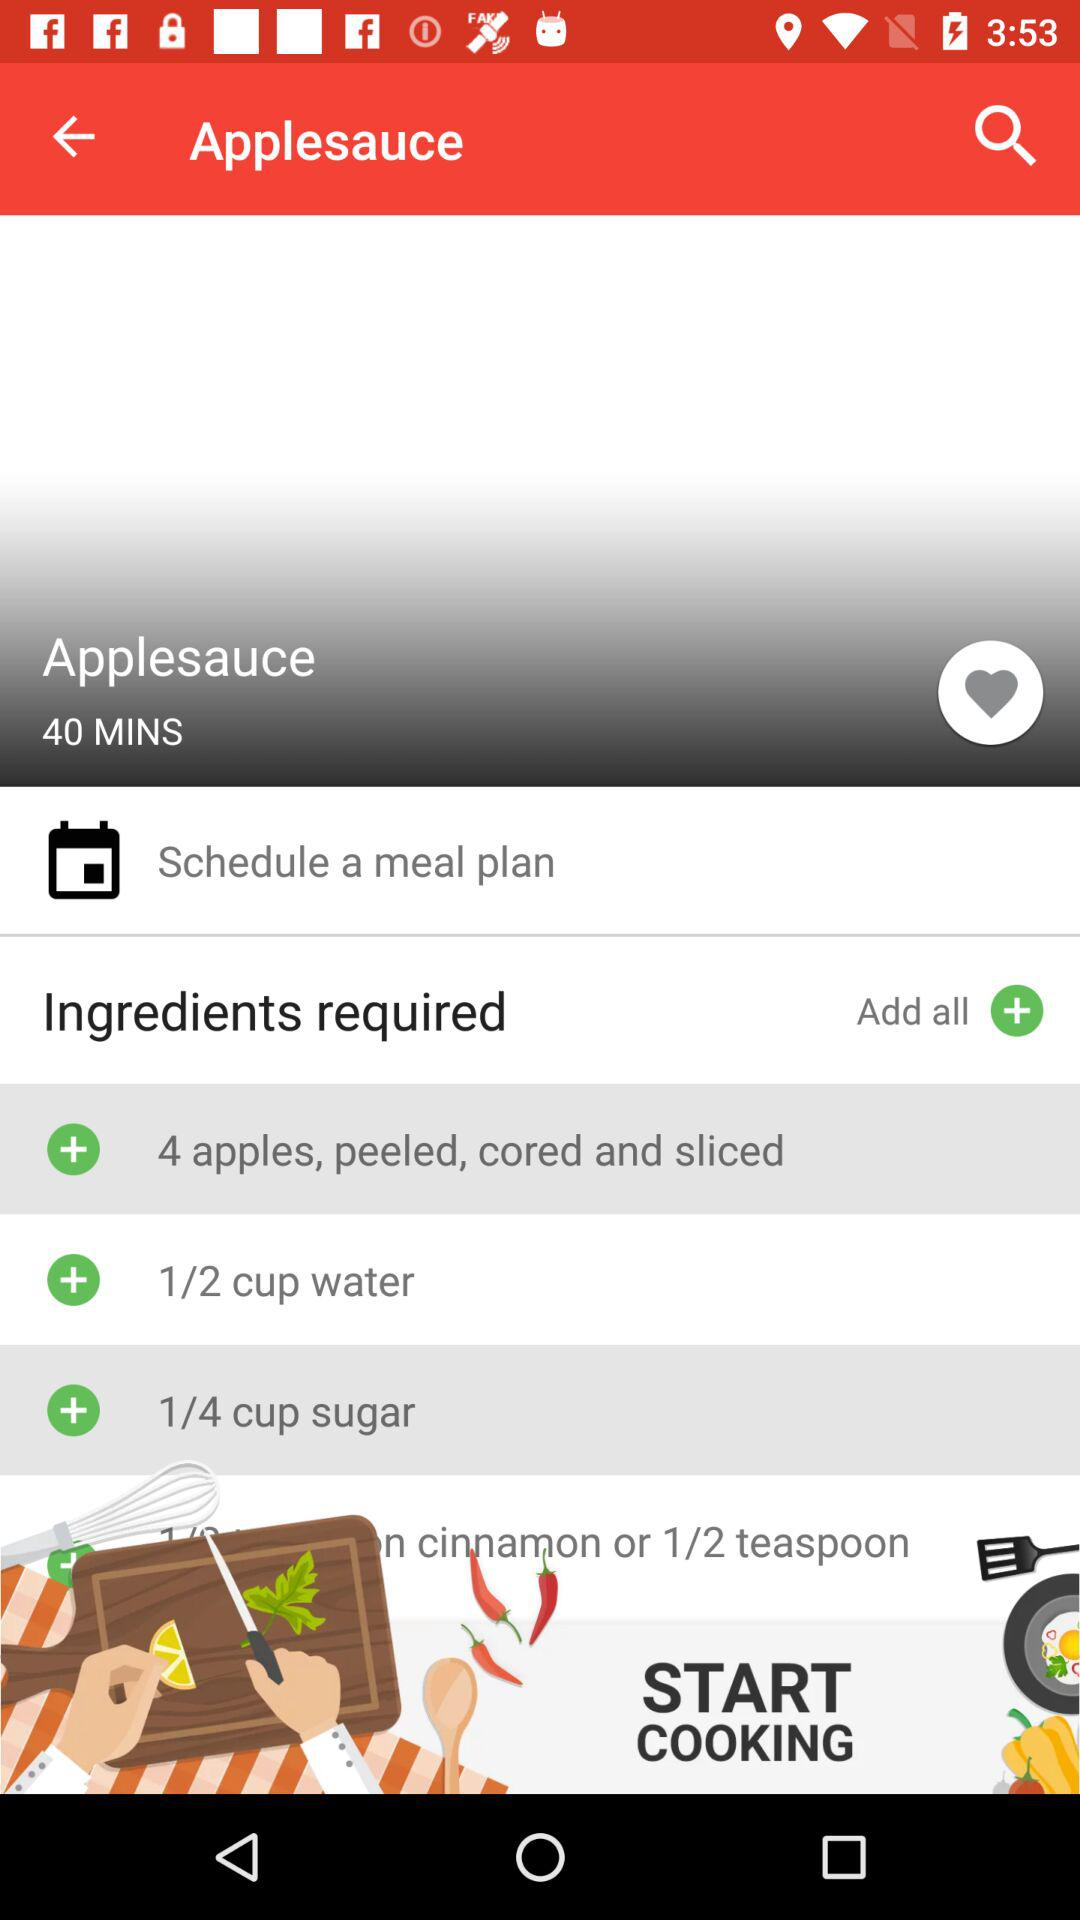How to Schedule a Meal Plan?
When the provided information is insufficient, respond with <no answer>. <no answer> 